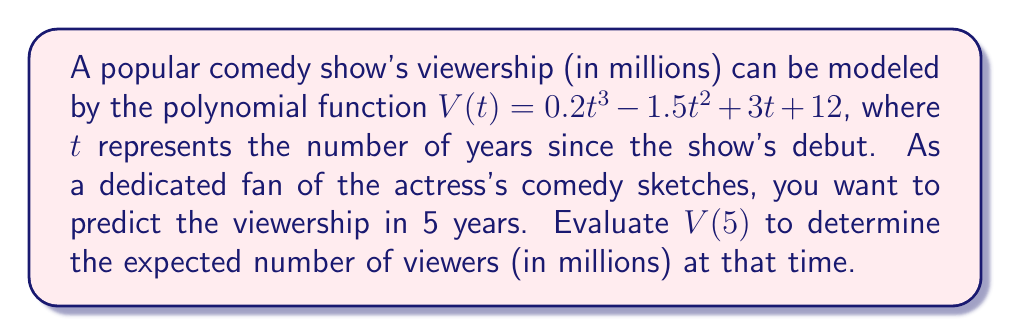Can you answer this question? To solve this problem, we need to evaluate the polynomial function $V(t)$ at $t = 5$. Let's break it down step by step:

1) The given function is $V(t) = 0.2t^3 - 1.5t^2 + 3t + 12$

2) We need to calculate $V(5)$, so we substitute $t = 5$ into the function:

   $V(5) = 0.2(5)^3 - 1.5(5)^2 + 3(5) + 12$

3) Let's evaluate each term:
   
   a) $0.2(5)^3 = 0.2 \times 125 = 25$
   b) $-1.5(5)^2 = -1.5 \times 25 = -37.5$
   c) $3(5) = 15$
   d) The constant term is already 12

4) Now, we sum all these terms:

   $V(5) = 25 - 37.5 + 15 + 12$

5) Calculating the final result:

   $V(5) = 14.5$

Therefore, in 5 years, the expected viewership of the show will be 14.5 million viewers.
Answer: 14.5 million viewers 